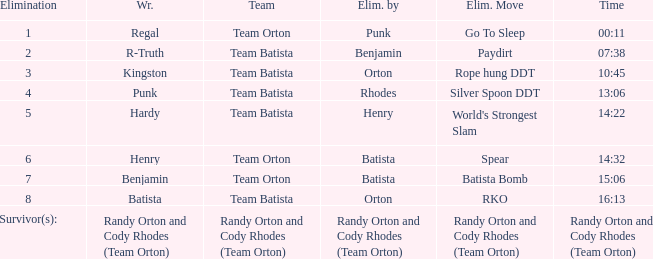Which Elimination move is listed against Team Orton, Eliminated by Batista against Elimination number 7? Batista Bomb. 